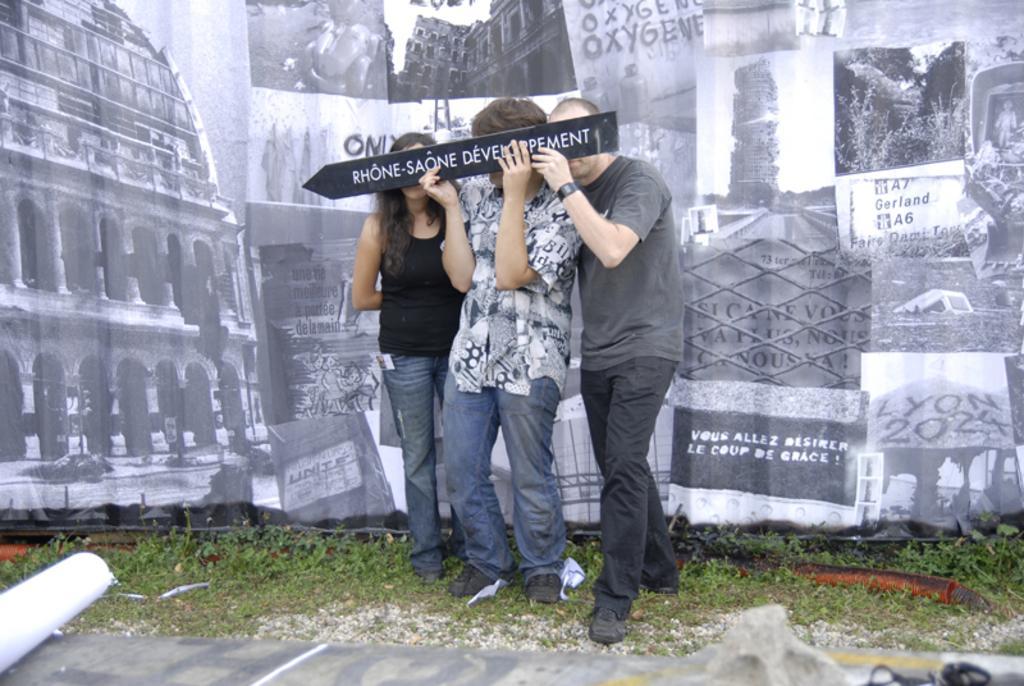How would you summarize this image in a sentence or two? In this image we can see three people standing on the ground. In that two are holding a signboard. We can also see some grass and a wall. 